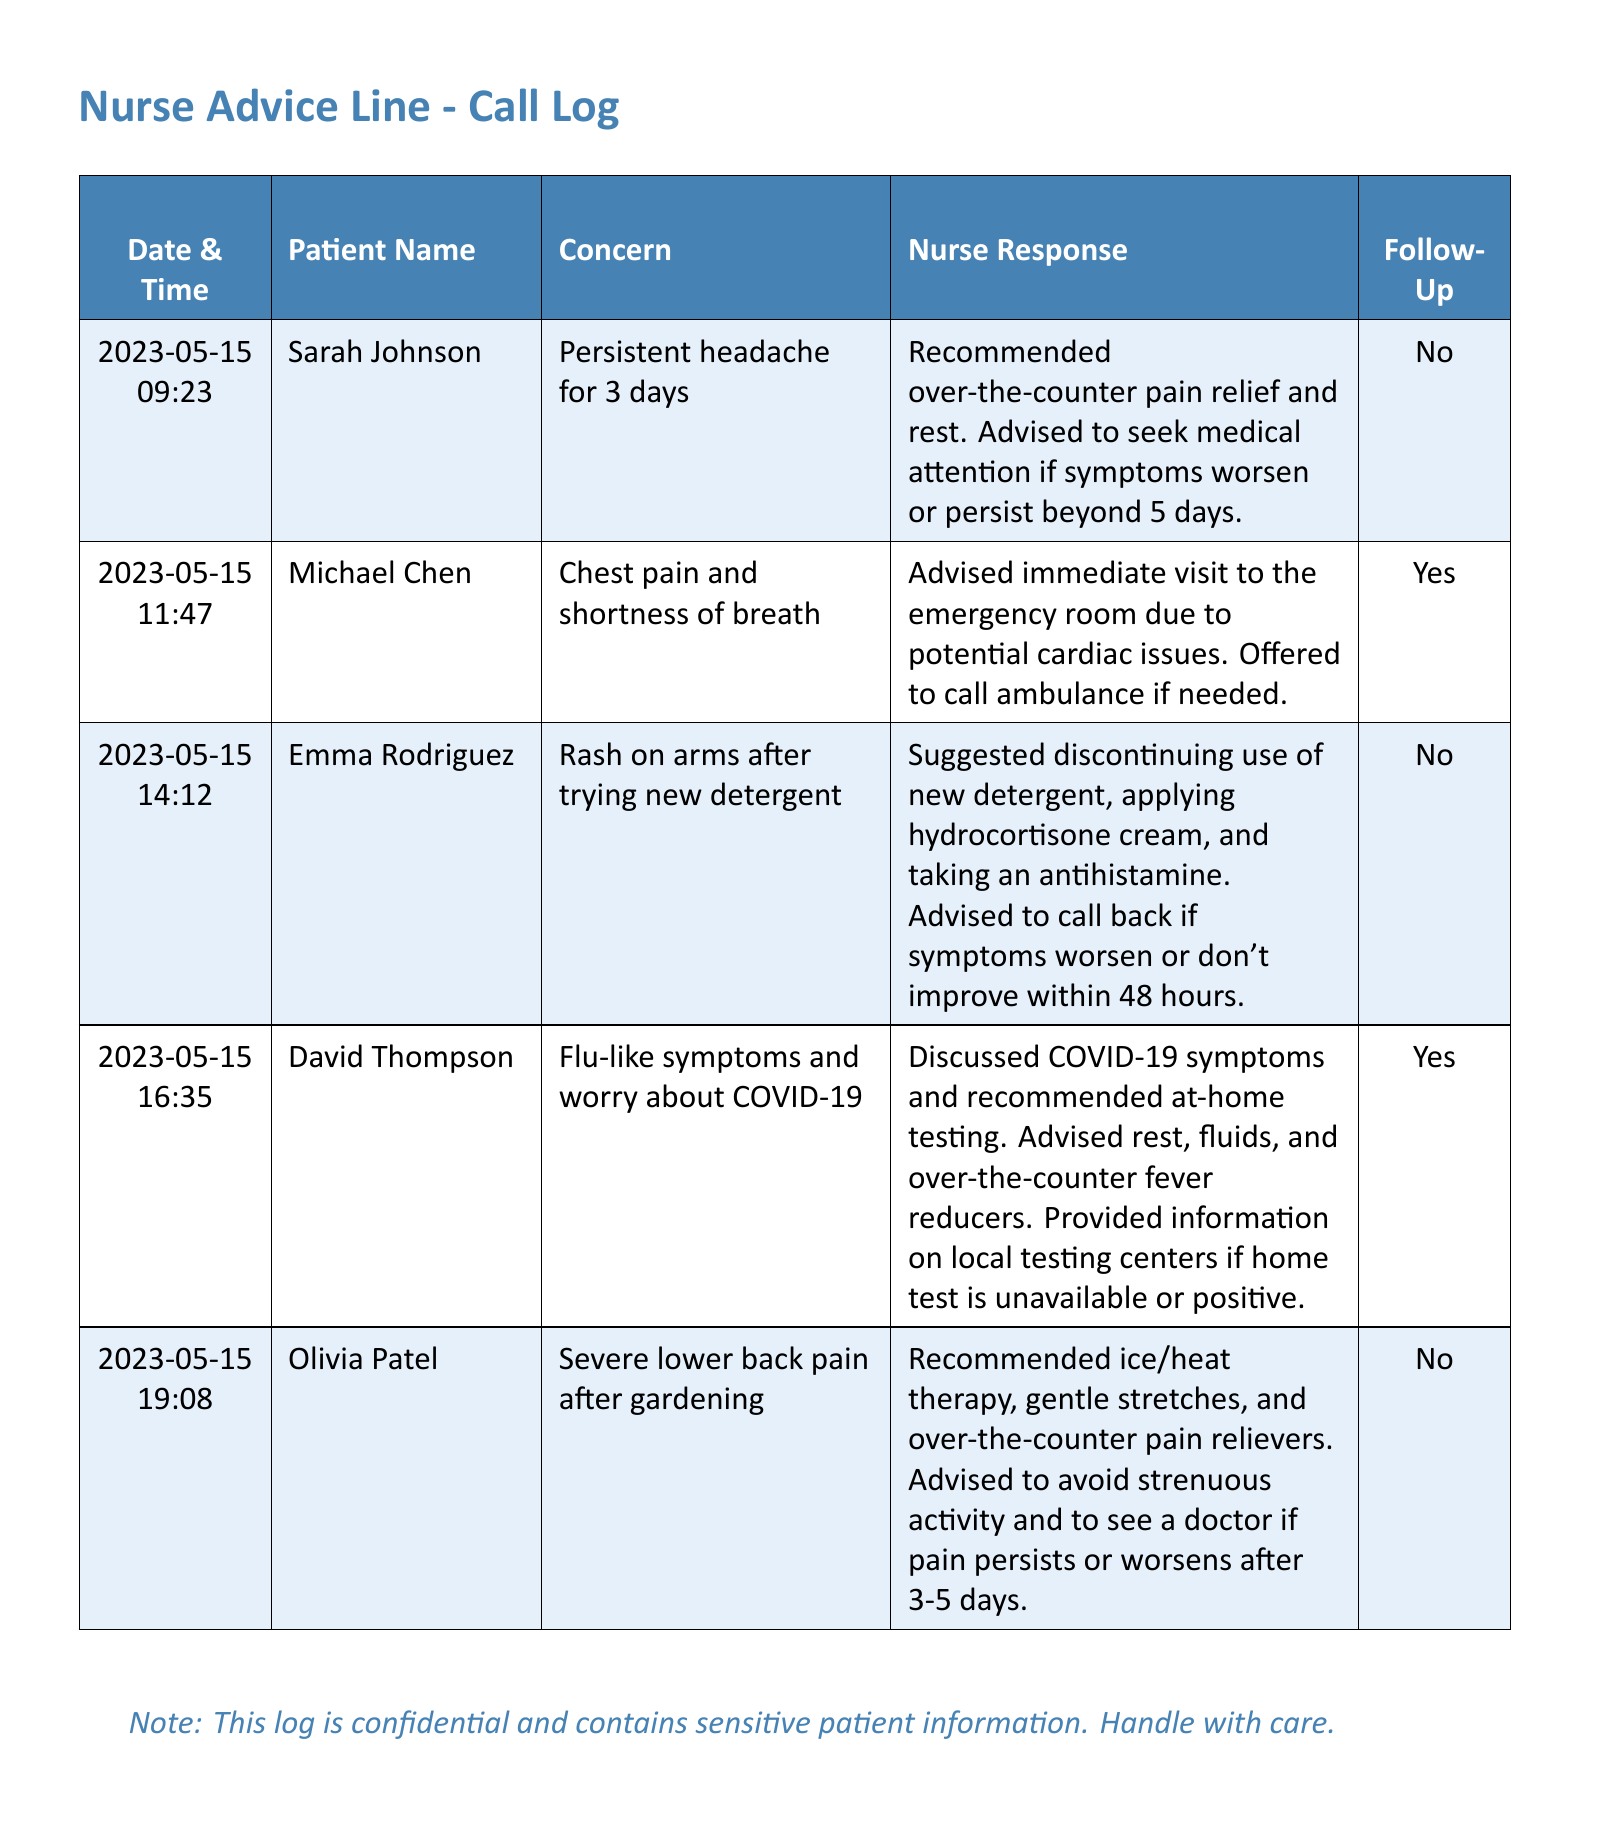What date did Sarah Johnson call? The call log indicates that Sarah Johnson called on 2023-05-15 at 09:23.
Answer: 2023-05-15 What was Michael Chen's concern? Michael Chen was concerned about chest pain and shortness of breath as noted in the call log.
Answer: Chest pain and shortness of breath What nurse response was given to Emma Rodriguez? The log indicates that the nurse suggested discontinuing the use of the new detergent and various treatments for the rash.
Answer: Discontinue new detergent, apply hydrocortisone cream, take antihistamine How long did David Thompson need to rest after his symptoms? The advice given to David Thompson mentioned resting and monitoring symptoms for potential evaluation if they worsen.
Answer: 3-5 days How many patients were advised to call back if symptoms worsened? A careful review of the call log shows that 2 patients were specifically advised to call back if their symptoms did not improve.
Answer: 2 What type of symptoms did Olivia Patel experience? According to the log, Olivia Patel experienced severe lower back pain after gardening.
Answer: Severe lower back pain What action was recommended for Michael Chen? The nurse response indicates that immediate action was necessary, recommending an emergency room visit due to possible serious cardiac issues.
Answer: Immediate visit to the emergency room What was the main concern of David Thompson? The log notes that David Thompson's main concern was flu-like symptoms and worry about COVID-19.
Answer: Flu-like symptoms and worry about COVID-19 What is the color of the header row in the log? The header row of the log is colored nurse blue, which is noted in the document.
Answer: Nurse blue What follow-up was advised for Sarah Johnson? The nurse response states that no follow-up was necessary for Sarah Johnson as her symptoms were monitored for a specific timeframe.
Answer: No 